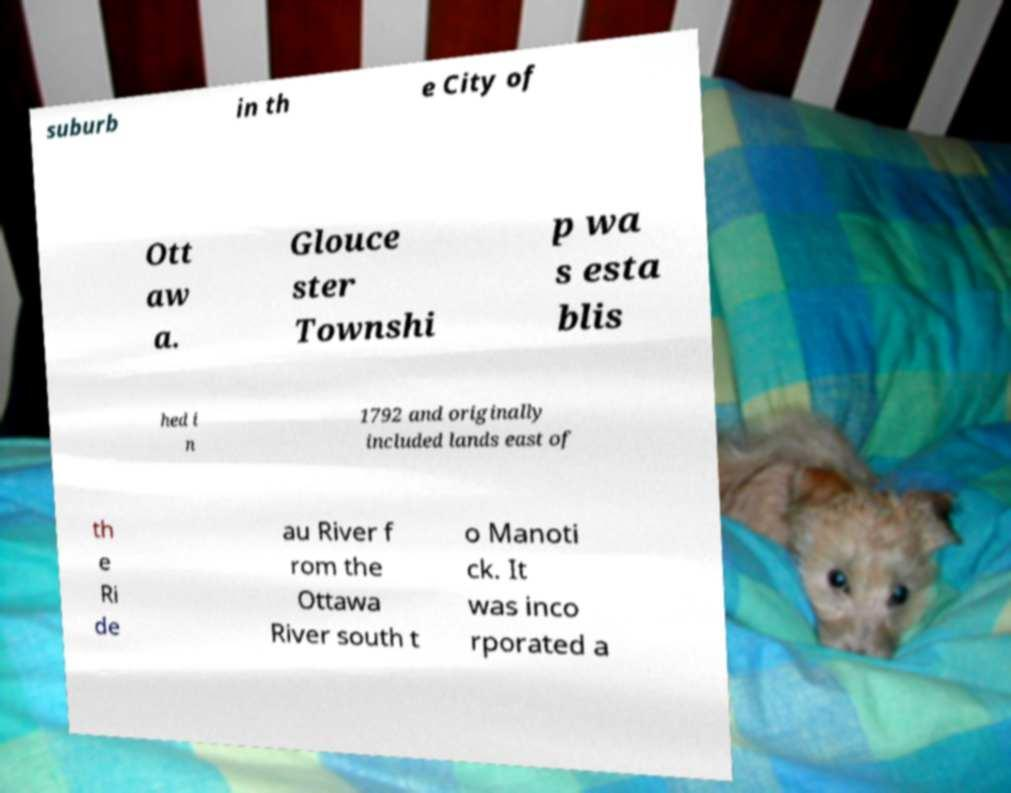Could you extract and type out the text from this image? suburb in th e City of Ott aw a. Glouce ster Townshi p wa s esta blis hed i n 1792 and originally included lands east of th e Ri de au River f rom the Ottawa River south t o Manoti ck. It was inco rporated a 